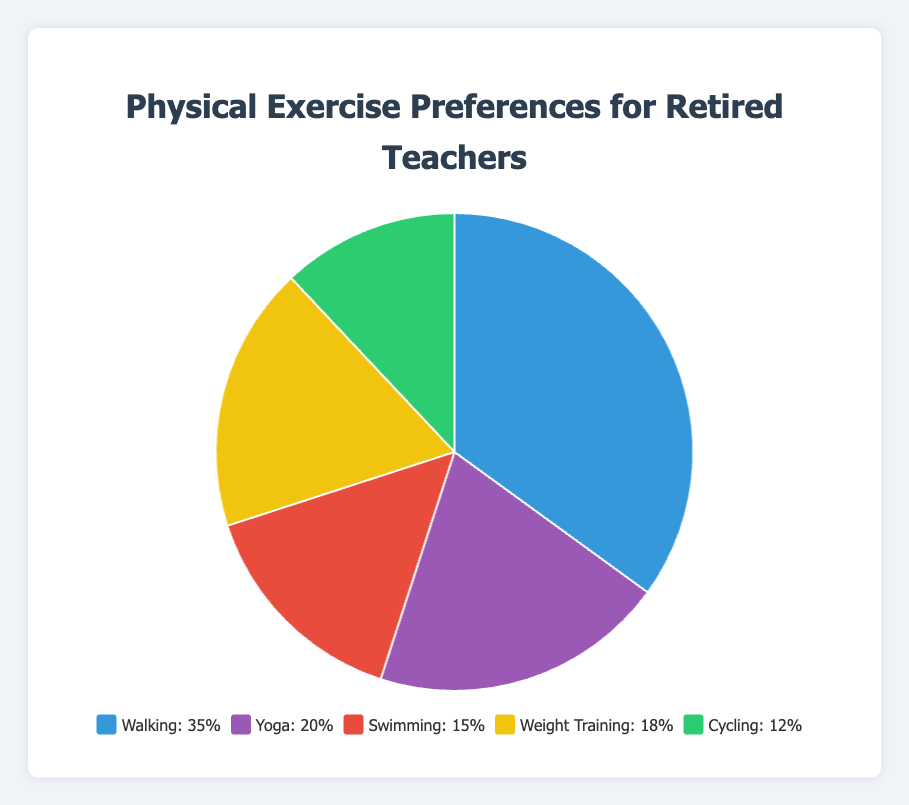What is the most popular exercise preference among retired teachers? By looking at the chart, we see that the largest segment belongs to Walking.
Answer: Walking Which exercise is the least preferred among the retirees? The smallest segment on the pie chart is for Cycling, indicating it is the least preferred.
Answer: Cycling What is the combined percentage for Yoga and Weight Training? Referring to the chart, Yoga is 20% and Weight Training is 18%. Adding these together, 20% + 18% = 38%.
Answer: 38% Is there a greater percentage of people who prefer Swimming or Cycling? The chart shows Swimming at 15% and Cycling at 12%. Since 15% is greater than 12%, more people prefer Swimming.
Answer: Swimming How much more popular is Walking compared to Weight Training? Walking has 35% and Weight Training has 18%. Subtracting these gives 35% - 18% = 17%.
Answer: 17% more popular What percentage of people prefer exercises other than Yoga? Exercises other than Yoga are Walking (35%), Swimming (15%), Weight Training (18%), and Cycling (12%). Adding these, 35% + 15% + 18% + 12% = 80%. Therefore, 100% - 20% (Yoga) = 80%.
Answer: 80% Which exercises have percentages that sum up to 50% or more when combined? The combinations that sum to 50% or more are Walking and Yoga (35% + 20% = 55%), Walking and Weight Training (35% + 18% = 53%), Walking and Swimming (35% + 15% = 50%), and Walking and Cycling (35% + 12% = 47%) assuming we add one more exercise preference to reach the threshold.
Answer: Walking and Yoga, Walking and Weight Training, Walking and Swimming What percentage of the chart is represented by the top two exercise preferences combined? The top two preferences, Walking (35%) and Yoga (20%), combined give 35% + 20% = 55%.
Answer: 55% 